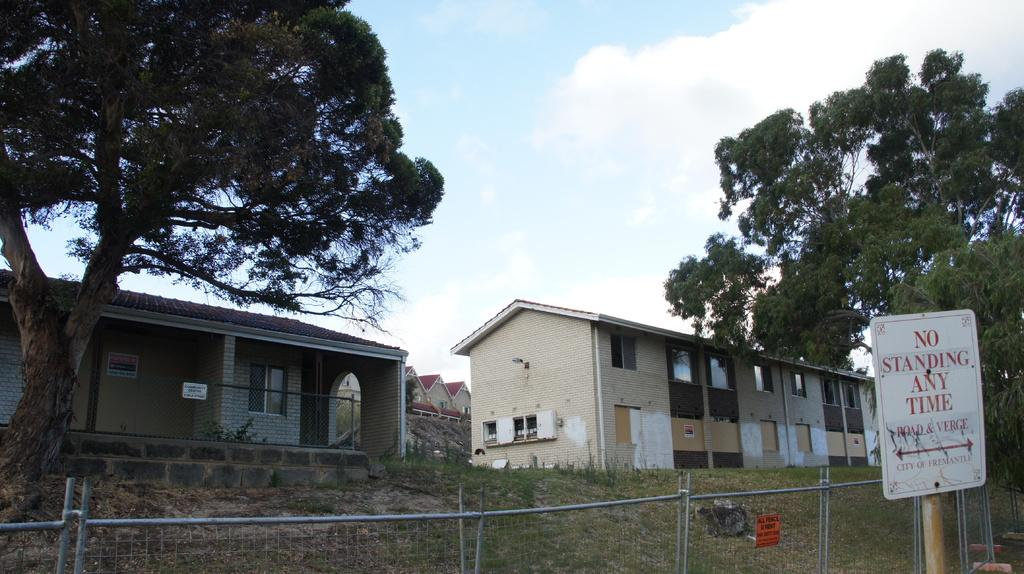What type of structures can be seen in the image? There are buildings in the image. What type of vegetation is present in the image? There are trees in the image, and there is grass on the ground. What is the purpose of the fence in the image? The purpose of the fence in the image is not explicitly stated, but it may be used to separate or enclose areas. What is written on the board in the image? The content of the text on the board is not specified, but it is mentioned that there is a board with text in the image. What is visible at the top of the image? The sky is visible at the top of the image. What color is the scarf that the tree is wearing in the image? There is no scarf present in the image, and trees do not wear scarves. What grade does the building in the image receive for its architectural design? The image does not provide any information about the architectural design of the building, nor does it mention any grades or evaluations. 